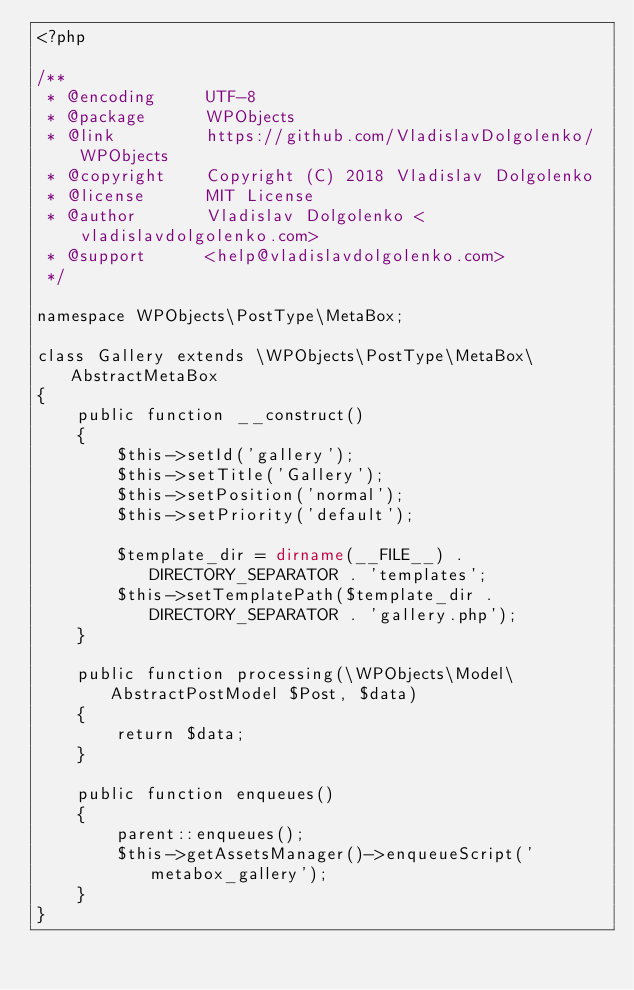Convert code to text. <code><loc_0><loc_0><loc_500><loc_500><_PHP_><?php

/**
 * @encoding     UTF-8
 * @package      WPObjects
 * @link         https://github.com/VladislavDolgolenko/WPObjects
 * @copyright    Copyright (C) 2018 Vladislav Dolgolenko
 * @license      MIT License
 * @author       Vladislav Dolgolenko <vladislavdolgolenko.com>
 * @support      <help@vladislavdolgolenko.com>
 */

namespace WPObjects\PostType\MetaBox;

class Gallery extends \WPObjects\PostType\MetaBox\AbstractMetaBox
{
    public function __construct()
    {
        $this->setId('gallery');
        $this->setTitle('Gallery');
        $this->setPosition('normal');
        $this->setPriority('default');
        
        $template_dir = dirname(__FILE__) . DIRECTORY_SEPARATOR . 'templates';
        $this->setTemplatePath($template_dir . DIRECTORY_SEPARATOR . 'gallery.php');
    }
    
    public function processing(\WPObjects\Model\AbstractPostModel $Post, $data)
    {
        return $data;
    }
    
    public function enqueues()
    {
        parent::enqueues();
        $this->getAssetsManager()->enqueueScript('metabox_gallery');
    }
}</code> 